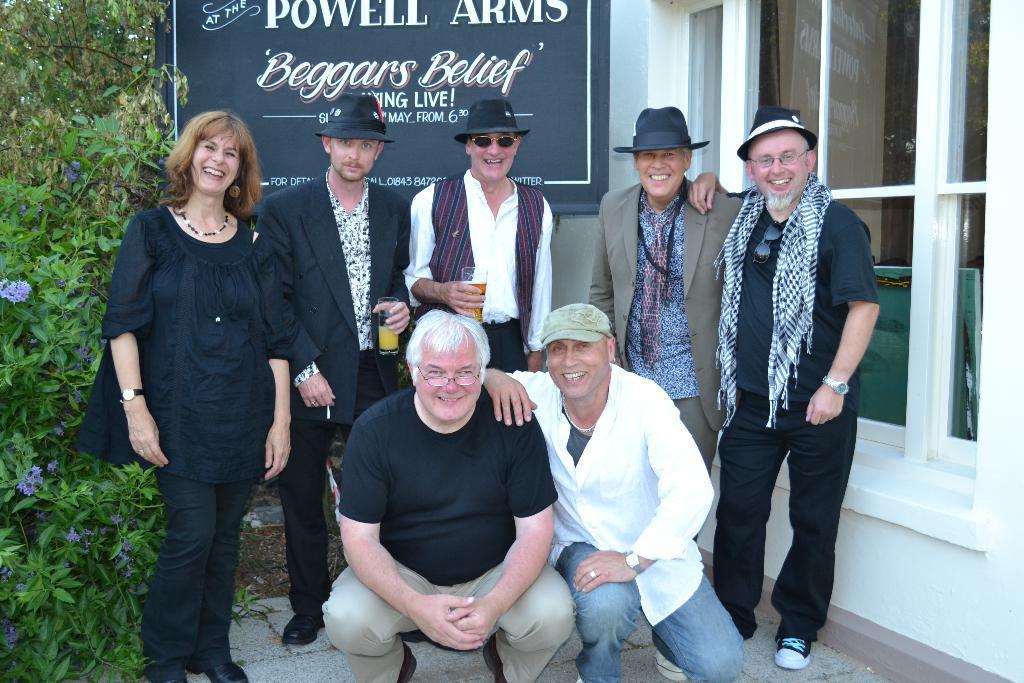Could you give a brief overview of what you see in this image? There are five people standing and smiling. I can see two men sitting in squat position and smiling. This is the name board. This looks like a glass window. Here is the tree with flowers. 